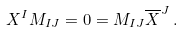Convert formula to latex. <formula><loc_0><loc_0><loc_500><loc_500>X ^ { I } M _ { I J } = 0 = M _ { I J } \overline { X } ^ { J } \, .</formula> 